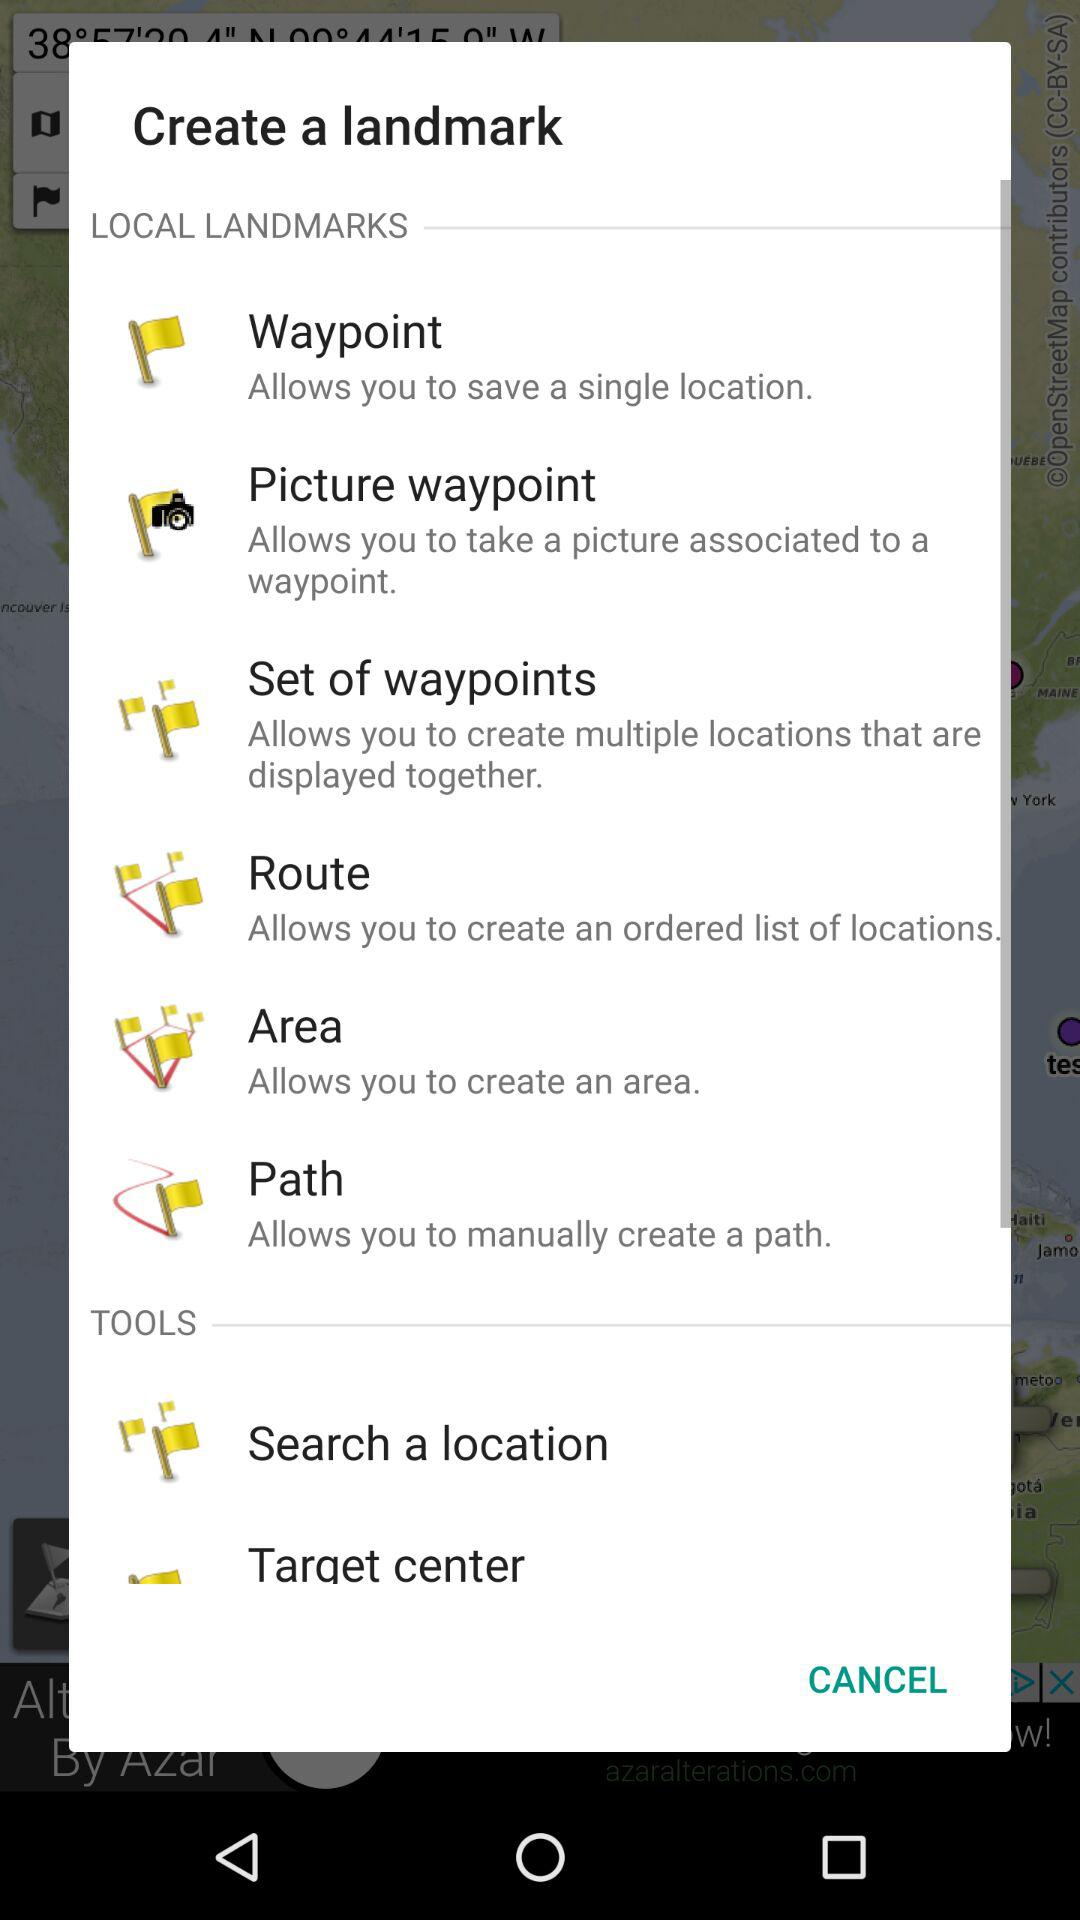What local landmark allows us to create an area? The local landmark is "Area". 